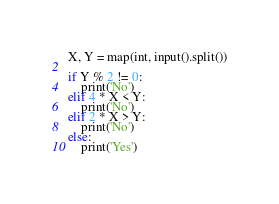<code> <loc_0><loc_0><loc_500><loc_500><_Python_>X, Y = map(int, input().split())

if Y % 2 != 0:
    print('No')
elif 4 * X < Y:
    print('No')
elif 2 * X > Y:
    print('No')
else:
    print('Yes')
</code> 